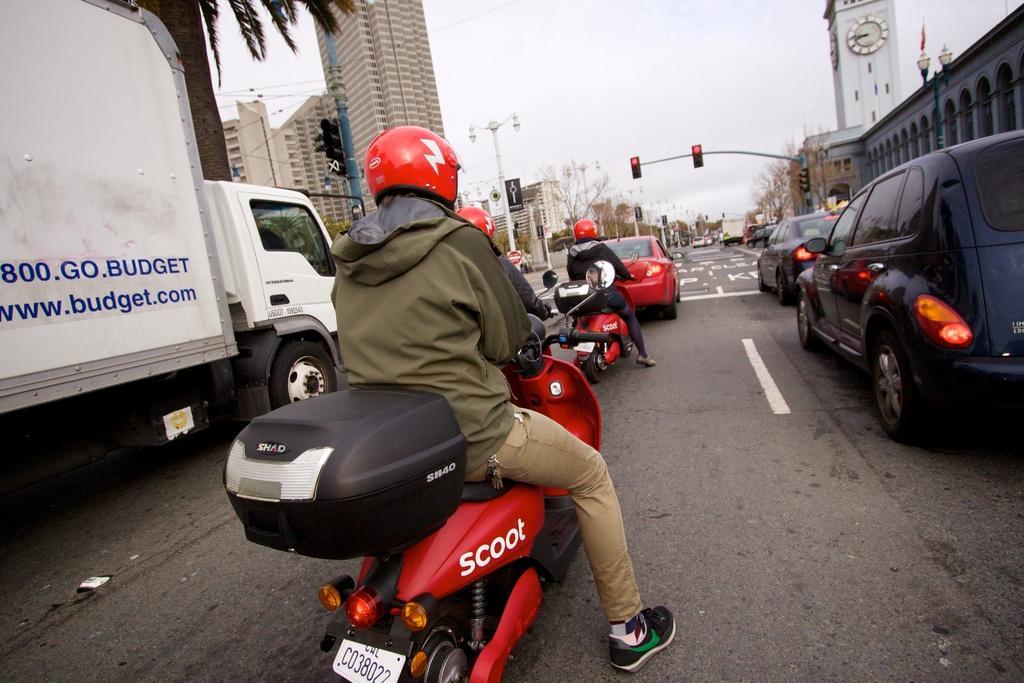How would you summarize this image in a sentence or two? This is clicked on road, there are few persons sitting on scooters with cars on right side and a truck on left side, in the back there are buildings all over the place with trees on either sides of the road. 